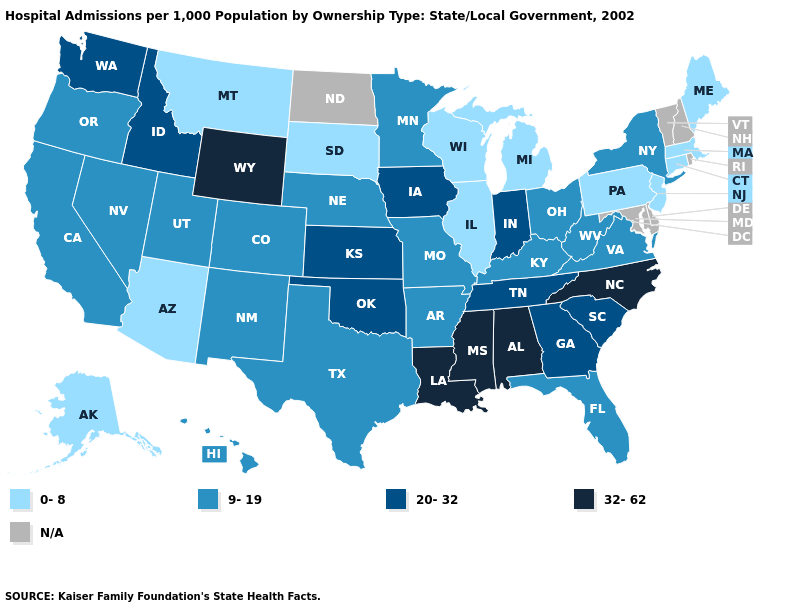What is the lowest value in the USA?
Write a very short answer. 0-8. What is the value of Montana?
Give a very brief answer. 0-8. What is the value of Massachusetts?
Give a very brief answer. 0-8. Name the states that have a value in the range 20-32?
Give a very brief answer. Georgia, Idaho, Indiana, Iowa, Kansas, Oklahoma, South Carolina, Tennessee, Washington. Does the map have missing data?
Be succinct. Yes. Name the states that have a value in the range 9-19?
Quick response, please. Arkansas, California, Colorado, Florida, Hawaii, Kentucky, Minnesota, Missouri, Nebraska, Nevada, New Mexico, New York, Ohio, Oregon, Texas, Utah, Virginia, West Virginia. Name the states that have a value in the range 20-32?
Write a very short answer. Georgia, Idaho, Indiana, Iowa, Kansas, Oklahoma, South Carolina, Tennessee, Washington. What is the value of Iowa?
Quick response, please. 20-32. Name the states that have a value in the range 20-32?
Write a very short answer. Georgia, Idaho, Indiana, Iowa, Kansas, Oklahoma, South Carolina, Tennessee, Washington. Name the states that have a value in the range 20-32?
Keep it brief. Georgia, Idaho, Indiana, Iowa, Kansas, Oklahoma, South Carolina, Tennessee, Washington. Does the map have missing data?
Short answer required. Yes. Name the states that have a value in the range 20-32?
Answer briefly. Georgia, Idaho, Indiana, Iowa, Kansas, Oklahoma, South Carolina, Tennessee, Washington. Which states have the lowest value in the MidWest?
Keep it brief. Illinois, Michigan, South Dakota, Wisconsin. Name the states that have a value in the range 9-19?
Answer briefly. Arkansas, California, Colorado, Florida, Hawaii, Kentucky, Minnesota, Missouri, Nebraska, Nevada, New Mexico, New York, Ohio, Oregon, Texas, Utah, Virginia, West Virginia. 